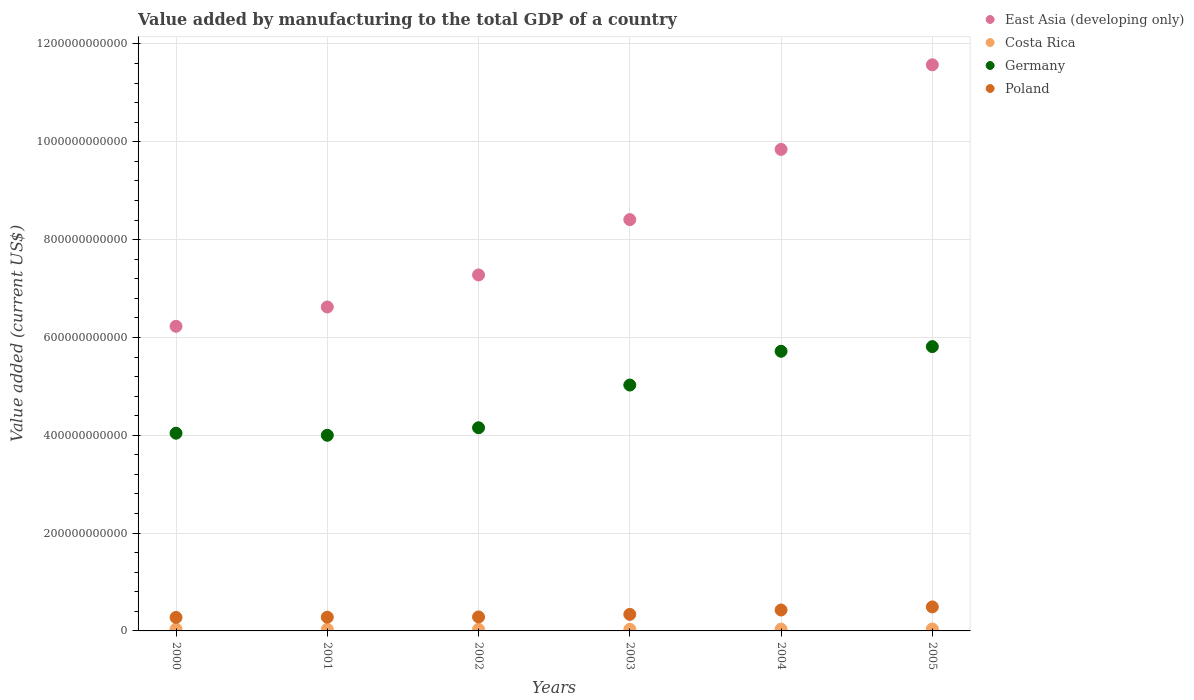How many different coloured dotlines are there?
Provide a succinct answer. 4. Is the number of dotlines equal to the number of legend labels?
Your response must be concise. Yes. What is the value added by manufacturing to the total GDP in Costa Rica in 2004?
Your answer should be very brief. 3.66e+09. Across all years, what is the maximum value added by manufacturing to the total GDP in Costa Rica?
Your answer should be very brief. 3.91e+09. Across all years, what is the minimum value added by manufacturing to the total GDP in East Asia (developing only)?
Your answer should be very brief. 6.23e+11. In which year was the value added by manufacturing to the total GDP in Germany maximum?
Your answer should be very brief. 2005. What is the total value added by manufacturing to the total GDP in Germany in the graph?
Your answer should be compact. 2.88e+12. What is the difference between the value added by manufacturing to the total GDP in East Asia (developing only) in 2000 and that in 2004?
Ensure brevity in your answer.  -3.62e+11. What is the difference between the value added by manufacturing to the total GDP in Poland in 2003 and the value added by manufacturing to the total GDP in East Asia (developing only) in 2005?
Make the answer very short. -1.12e+12. What is the average value added by manufacturing to the total GDP in Costa Rica per year?
Give a very brief answer. 3.52e+09. In the year 2005, what is the difference between the value added by manufacturing to the total GDP in Germany and value added by manufacturing to the total GDP in Costa Rica?
Your response must be concise. 5.77e+11. In how many years, is the value added by manufacturing to the total GDP in Germany greater than 720000000000 US$?
Offer a very short reply. 0. What is the ratio of the value added by manufacturing to the total GDP in East Asia (developing only) in 2001 to that in 2002?
Keep it short and to the point. 0.91. Is the value added by manufacturing to the total GDP in Poland in 2004 less than that in 2005?
Provide a short and direct response. Yes. What is the difference between the highest and the second highest value added by manufacturing to the total GDP in Poland?
Offer a very short reply. 6.30e+09. What is the difference between the highest and the lowest value added by manufacturing to the total GDP in Poland?
Offer a terse response. 2.16e+1. Is the sum of the value added by manufacturing to the total GDP in Germany in 2003 and 2005 greater than the maximum value added by manufacturing to the total GDP in East Asia (developing only) across all years?
Make the answer very short. No. Is it the case that in every year, the sum of the value added by manufacturing to the total GDP in Poland and value added by manufacturing to the total GDP in Costa Rica  is greater than the value added by manufacturing to the total GDP in Germany?
Provide a short and direct response. No. Does the value added by manufacturing to the total GDP in Germany monotonically increase over the years?
Provide a short and direct response. No. Is the value added by manufacturing to the total GDP in Germany strictly greater than the value added by manufacturing to the total GDP in Poland over the years?
Give a very brief answer. Yes. Is the value added by manufacturing to the total GDP in Germany strictly less than the value added by manufacturing to the total GDP in Costa Rica over the years?
Ensure brevity in your answer.  No. What is the difference between two consecutive major ticks on the Y-axis?
Give a very brief answer. 2.00e+11. Are the values on the major ticks of Y-axis written in scientific E-notation?
Provide a succinct answer. No. Does the graph contain any zero values?
Provide a short and direct response. No. Where does the legend appear in the graph?
Provide a short and direct response. Top right. How many legend labels are there?
Give a very brief answer. 4. What is the title of the graph?
Offer a very short reply. Value added by manufacturing to the total GDP of a country. What is the label or title of the X-axis?
Keep it short and to the point. Years. What is the label or title of the Y-axis?
Provide a short and direct response. Value added (current US$). What is the Value added (current US$) of East Asia (developing only) in 2000?
Provide a succinct answer. 6.23e+11. What is the Value added (current US$) of Costa Rica in 2000?
Provide a short and direct response. 3.68e+09. What is the Value added (current US$) of Germany in 2000?
Keep it short and to the point. 4.04e+11. What is the Value added (current US$) of Poland in 2000?
Offer a terse response. 2.75e+1. What is the Value added (current US$) in East Asia (developing only) in 2001?
Give a very brief answer. 6.62e+11. What is the Value added (current US$) of Costa Rica in 2001?
Offer a terse response. 3.24e+09. What is the Value added (current US$) in Germany in 2001?
Give a very brief answer. 4.00e+11. What is the Value added (current US$) of Poland in 2001?
Ensure brevity in your answer.  2.81e+1. What is the Value added (current US$) of East Asia (developing only) in 2002?
Your answer should be very brief. 7.28e+11. What is the Value added (current US$) of Costa Rica in 2002?
Your answer should be very brief. 3.28e+09. What is the Value added (current US$) in Germany in 2002?
Your answer should be compact. 4.15e+11. What is the Value added (current US$) of Poland in 2002?
Your answer should be very brief. 2.85e+1. What is the Value added (current US$) in East Asia (developing only) in 2003?
Provide a short and direct response. 8.41e+11. What is the Value added (current US$) in Costa Rica in 2003?
Ensure brevity in your answer.  3.36e+09. What is the Value added (current US$) of Germany in 2003?
Your answer should be very brief. 5.03e+11. What is the Value added (current US$) of Poland in 2003?
Give a very brief answer. 3.39e+1. What is the Value added (current US$) of East Asia (developing only) in 2004?
Your answer should be very brief. 9.84e+11. What is the Value added (current US$) in Costa Rica in 2004?
Give a very brief answer. 3.66e+09. What is the Value added (current US$) in Germany in 2004?
Your answer should be compact. 5.72e+11. What is the Value added (current US$) of Poland in 2004?
Your response must be concise. 4.28e+1. What is the Value added (current US$) in East Asia (developing only) in 2005?
Your answer should be compact. 1.16e+12. What is the Value added (current US$) of Costa Rica in 2005?
Offer a terse response. 3.91e+09. What is the Value added (current US$) in Germany in 2005?
Offer a terse response. 5.81e+11. What is the Value added (current US$) of Poland in 2005?
Offer a terse response. 4.91e+1. Across all years, what is the maximum Value added (current US$) in East Asia (developing only)?
Make the answer very short. 1.16e+12. Across all years, what is the maximum Value added (current US$) in Costa Rica?
Your answer should be very brief. 3.91e+09. Across all years, what is the maximum Value added (current US$) of Germany?
Your response must be concise. 5.81e+11. Across all years, what is the maximum Value added (current US$) in Poland?
Your answer should be compact. 4.91e+1. Across all years, what is the minimum Value added (current US$) of East Asia (developing only)?
Your response must be concise. 6.23e+11. Across all years, what is the minimum Value added (current US$) in Costa Rica?
Offer a very short reply. 3.24e+09. Across all years, what is the minimum Value added (current US$) in Germany?
Ensure brevity in your answer.  4.00e+11. Across all years, what is the minimum Value added (current US$) of Poland?
Keep it short and to the point. 2.75e+1. What is the total Value added (current US$) of East Asia (developing only) in the graph?
Your answer should be very brief. 5.00e+12. What is the total Value added (current US$) in Costa Rica in the graph?
Give a very brief answer. 2.11e+1. What is the total Value added (current US$) in Germany in the graph?
Your answer should be very brief. 2.88e+12. What is the total Value added (current US$) of Poland in the graph?
Make the answer very short. 2.10e+11. What is the difference between the Value added (current US$) of East Asia (developing only) in 2000 and that in 2001?
Offer a terse response. -3.94e+1. What is the difference between the Value added (current US$) in Costa Rica in 2000 and that in 2001?
Provide a short and direct response. 4.34e+08. What is the difference between the Value added (current US$) of Germany in 2000 and that in 2001?
Keep it short and to the point. 4.21e+09. What is the difference between the Value added (current US$) of Poland in 2000 and that in 2001?
Keep it short and to the point. -5.80e+08. What is the difference between the Value added (current US$) in East Asia (developing only) in 2000 and that in 2002?
Your response must be concise. -1.05e+11. What is the difference between the Value added (current US$) of Costa Rica in 2000 and that in 2002?
Give a very brief answer. 4.00e+08. What is the difference between the Value added (current US$) in Germany in 2000 and that in 2002?
Give a very brief answer. -1.12e+1. What is the difference between the Value added (current US$) of Poland in 2000 and that in 2002?
Provide a succinct answer. -1.02e+09. What is the difference between the Value added (current US$) in East Asia (developing only) in 2000 and that in 2003?
Your answer should be very brief. -2.18e+11. What is the difference between the Value added (current US$) of Costa Rica in 2000 and that in 2003?
Offer a very short reply. 3.16e+08. What is the difference between the Value added (current US$) of Germany in 2000 and that in 2003?
Provide a succinct answer. -9.85e+1. What is the difference between the Value added (current US$) of Poland in 2000 and that in 2003?
Provide a short and direct response. -6.33e+09. What is the difference between the Value added (current US$) in East Asia (developing only) in 2000 and that in 2004?
Offer a very short reply. -3.62e+11. What is the difference between the Value added (current US$) in Costa Rica in 2000 and that in 2004?
Offer a very short reply. 1.61e+07. What is the difference between the Value added (current US$) of Germany in 2000 and that in 2004?
Make the answer very short. -1.68e+11. What is the difference between the Value added (current US$) in Poland in 2000 and that in 2004?
Your response must be concise. -1.53e+1. What is the difference between the Value added (current US$) in East Asia (developing only) in 2000 and that in 2005?
Your answer should be very brief. -5.35e+11. What is the difference between the Value added (current US$) in Costa Rica in 2000 and that in 2005?
Keep it short and to the point. -2.38e+08. What is the difference between the Value added (current US$) in Germany in 2000 and that in 2005?
Make the answer very short. -1.77e+11. What is the difference between the Value added (current US$) of Poland in 2000 and that in 2005?
Your answer should be very brief. -2.16e+1. What is the difference between the Value added (current US$) in East Asia (developing only) in 2001 and that in 2002?
Provide a short and direct response. -6.55e+1. What is the difference between the Value added (current US$) of Costa Rica in 2001 and that in 2002?
Provide a succinct answer. -3.42e+07. What is the difference between the Value added (current US$) of Germany in 2001 and that in 2002?
Offer a terse response. -1.54e+1. What is the difference between the Value added (current US$) of Poland in 2001 and that in 2002?
Make the answer very short. -4.39e+08. What is the difference between the Value added (current US$) of East Asia (developing only) in 2001 and that in 2003?
Give a very brief answer. -1.79e+11. What is the difference between the Value added (current US$) in Costa Rica in 2001 and that in 2003?
Offer a terse response. -1.18e+08. What is the difference between the Value added (current US$) of Germany in 2001 and that in 2003?
Your answer should be very brief. -1.03e+11. What is the difference between the Value added (current US$) of Poland in 2001 and that in 2003?
Make the answer very short. -5.75e+09. What is the difference between the Value added (current US$) of East Asia (developing only) in 2001 and that in 2004?
Keep it short and to the point. -3.22e+11. What is the difference between the Value added (current US$) of Costa Rica in 2001 and that in 2004?
Keep it short and to the point. -4.18e+08. What is the difference between the Value added (current US$) in Germany in 2001 and that in 2004?
Provide a short and direct response. -1.72e+11. What is the difference between the Value added (current US$) of Poland in 2001 and that in 2004?
Your answer should be compact. -1.47e+1. What is the difference between the Value added (current US$) in East Asia (developing only) in 2001 and that in 2005?
Offer a terse response. -4.95e+11. What is the difference between the Value added (current US$) of Costa Rica in 2001 and that in 2005?
Provide a short and direct response. -6.72e+08. What is the difference between the Value added (current US$) of Germany in 2001 and that in 2005?
Offer a very short reply. -1.81e+11. What is the difference between the Value added (current US$) of Poland in 2001 and that in 2005?
Give a very brief answer. -2.10e+1. What is the difference between the Value added (current US$) in East Asia (developing only) in 2002 and that in 2003?
Make the answer very short. -1.13e+11. What is the difference between the Value added (current US$) of Costa Rica in 2002 and that in 2003?
Your answer should be compact. -8.42e+07. What is the difference between the Value added (current US$) in Germany in 2002 and that in 2003?
Your answer should be very brief. -8.73e+1. What is the difference between the Value added (current US$) in Poland in 2002 and that in 2003?
Make the answer very short. -5.31e+09. What is the difference between the Value added (current US$) in East Asia (developing only) in 2002 and that in 2004?
Ensure brevity in your answer.  -2.57e+11. What is the difference between the Value added (current US$) in Costa Rica in 2002 and that in 2004?
Keep it short and to the point. -3.84e+08. What is the difference between the Value added (current US$) of Germany in 2002 and that in 2004?
Make the answer very short. -1.56e+11. What is the difference between the Value added (current US$) of Poland in 2002 and that in 2004?
Make the answer very short. -1.42e+1. What is the difference between the Value added (current US$) of East Asia (developing only) in 2002 and that in 2005?
Ensure brevity in your answer.  -4.30e+11. What is the difference between the Value added (current US$) of Costa Rica in 2002 and that in 2005?
Provide a succinct answer. -6.38e+08. What is the difference between the Value added (current US$) in Germany in 2002 and that in 2005?
Ensure brevity in your answer.  -1.66e+11. What is the difference between the Value added (current US$) in Poland in 2002 and that in 2005?
Offer a terse response. -2.05e+1. What is the difference between the Value added (current US$) of East Asia (developing only) in 2003 and that in 2004?
Ensure brevity in your answer.  -1.44e+11. What is the difference between the Value added (current US$) of Costa Rica in 2003 and that in 2004?
Offer a terse response. -3.00e+08. What is the difference between the Value added (current US$) in Germany in 2003 and that in 2004?
Keep it short and to the point. -6.90e+1. What is the difference between the Value added (current US$) of Poland in 2003 and that in 2004?
Make the answer very short. -8.92e+09. What is the difference between the Value added (current US$) of East Asia (developing only) in 2003 and that in 2005?
Give a very brief answer. -3.17e+11. What is the difference between the Value added (current US$) of Costa Rica in 2003 and that in 2005?
Offer a terse response. -5.53e+08. What is the difference between the Value added (current US$) in Germany in 2003 and that in 2005?
Ensure brevity in your answer.  -7.86e+1. What is the difference between the Value added (current US$) in Poland in 2003 and that in 2005?
Offer a very short reply. -1.52e+1. What is the difference between the Value added (current US$) of East Asia (developing only) in 2004 and that in 2005?
Ensure brevity in your answer.  -1.73e+11. What is the difference between the Value added (current US$) of Costa Rica in 2004 and that in 2005?
Give a very brief answer. -2.54e+08. What is the difference between the Value added (current US$) of Germany in 2004 and that in 2005?
Give a very brief answer. -9.54e+09. What is the difference between the Value added (current US$) in Poland in 2004 and that in 2005?
Offer a terse response. -6.30e+09. What is the difference between the Value added (current US$) in East Asia (developing only) in 2000 and the Value added (current US$) in Costa Rica in 2001?
Your answer should be very brief. 6.20e+11. What is the difference between the Value added (current US$) of East Asia (developing only) in 2000 and the Value added (current US$) of Germany in 2001?
Make the answer very short. 2.23e+11. What is the difference between the Value added (current US$) of East Asia (developing only) in 2000 and the Value added (current US$) of Poland in 2001?
Provide a succinct answer. 5.95e+11. What is the difference between the Value added (current US$) of Costa Rica in 2000 and the Value added (current US$) of Germany in 2001?
Provide a short and direct response. -3.96e+11. What is the difference between the Value added (current US$) of Costa Rica in 2000 and the Value added (current US$) of Poland in 2001?
Make the answer very short. -2.44e+1. What is the difference between the Value added (current US$) of Germany in 2000 and the Value added (current US$) of Poland in 2001?
Your answer should be compact. 3.76e+11. What is the difference between the Value added (current US$) in East Asia (developing only) in 2000 and the Value added (current US$) in Costa Rica in 2002?
Your response must be concise. 6.20e+11. What is the difference between the Value added (current US$) of East Asia (developing only) in 2000 and the Value added (current US$) of Germany in 2002?
Provide a short and direct response. 2.07e+11. What is the difference between the Value added (current US$) in East Asia (developing only) in 2000 and the Value added (current US$) in Poland in 2002?
Your answer should be very brief. 5.94e+11. What is the difference between the Value added (current US$) in Costa Rica in 2000 and the Value added (current US$) in Germany in 2002?
Provide a succinct answer. -4.12e+11. What is the difference between the Value added (current US$) of Costa Rica in 2000 and the Value added (current US$) of Poland in 2002?
Your answer should be compact. -2.49e+1. What is the difference between the Value added (current US$) in Germany in 2000 and the Value added (current US$) in Poland in 2002?
Keep it short and to the point. 3.76e+11. What is the difference between the Value added (current US$) of East Asia (developing only) in 2000 and the Value added (current US$) of Costa Rica in 2003?
Make the answer very short. 6.19e+11. What is the difference between the Value added (current US$) of East Asia (developing only) in 2000 and the Value added (current US$) of Germany in 2003?
Give a very brief answer. 1.20e+11. What is the difference between the Value added (current US$) in East Asia (developing only) in 2000 and the Value added (current US$) in Poland in 2003?
Your answer should be very brief. 5.89e+11. What is the difference between the Value added (current US$) in Costa Rica in 2000 and the Value added (current US$) in Germany in 2003?
Make the answer very short. -4.99e+11. What is the difference between the Value added (current US$) in Costa Rica in 2000 and the Value added (current US$) in Poland in 2003?
Offer a very short reply. -3.02e+1. What is the difference between the Value added (current US$) of Germany in 2000 and the Value added (current US$) of Poland in 2003?
Make the answer very short. 3.70e+11. What is the difference between the Value added (current US$) in East Asia (developing only) in 2000 and the Value added (current US$) in Costa Rica in 2004?
Provide a short and direct response. 6.19e+11. What is the difference between the Value added (current US$) in East Asia (developing only) in 2000 and the Value added (current US$) in Germany in 2004?
Provide a short and direct response. 5.11e+1. What is the difference between the Value added (current US$) of East Asia (developing only) in 2000 and the Value added (current US$) of Poland in 2004?
Your answer should be compact. 5.80e+11. What is the difference between the Value added (current US$) in Costa Rica in 2000 and the Value added (current US$) in Germany in 2004?
Provide a short and direct response. -5.68e+11. What is the difference between the Value added (current US$) of Costa Rica in 2000 and the Value added (current US$) of Poland in 2004?
Ensure brevity in your answer.  -3.91e+1. What is the difference between the Value added (current US$) in Germany in 2000 and the Value added (current US$) in Poland in 2004?
Ensure brevity in your answer.  3.61e+11. What is the difference between the Value added (current US$) of East Asia (developing only) in 2000 and the Value added (current US$) of Costa Rica in 2005?
Provide a short and direct response. 6.19e+11. What is the difference between the Value added (current US$) in East Asia (developing only) in 2000 and the Value added (current US$) in Germany in 2005?
Make the answer very short. 4.16e+1. What is the difference between the Value added (current US$) of East Asia (developing only) in 2000 and the Value added (current US$) of Poland in 2005?
Offer a terse response. 5.74e+11. What is the difference between the Value added (current US$) of Costa Rica in 2000 and the Value added (current US$) of Germany in 2005?
Offer a very short reply. -5.78e+11. What is the difference between the Value added (current US$) in Costa Rica in 2000 and the Value added (current US$) in Poland in 2005?
Your answer should be very brief. -4.54e+1. What is the difference between the Value added (current US$) in Germany in 2000 and the Value added (current US$) in Poland in 2005?
Your answer should be very brief. 3.55e+11. What is the difference between the Value added (current US$) in East Asia (developing only) in 2001 and the Value added (current US$) in Costa Rica in 2002?
Offer a terse response. 6.59e+11. What is the difference between the Value added (current US$) of East Asia (developing only) in 2001 and the Value added (current US$) of Germany in 2002?
Offer a terse response. 2.47e+11. What is the difference between the Value added (current US$) in East Asia (developing only) in 2001 and the Value added (current US$) in Poland in 2002?
Offer a very short reply. 6.34e+11. What is the difference between the Value added (current US$) in Costa Rica in 2001 and the Value added (current US$) in Germany in 2002?
Give a very brief answer. -4.12e+11. What is the difference between the Value added (current US$) of Costa Rica in 2001 and the Value added (current US$) of Poland in 2002?
Provide a short and direct response. -2.53e+1. What is the difference between the Value added (current US$) in Germany in 2001 and the Value added (current US$) in Poland in 2002?
Your response must be concise. 3.71e+11. What is the difference between the Value added (current US$) of East Asia (developing only) in 2001 and the Value added (current US$) of Costa Rica in 2003?
Your response must be concise. 6.59e+11. What is the difference between the Value added (current US$) of East Asia (developing only) in 2001 and the Value added (current US$) of Germany in 2003?
Your answer should be compact. 1.60e+11. What is the difference between the Value added (current US$) in East Asia (developing only) in 2001 and the Value added (current US$) in Poland in 2003?
Offer a terse response. 6.28e+11. What is the difference between the Value added (current US$) in Costa Rica in 2001 and the Value added (current US$) in Germany in 2003?
Your response must be concise. -4.99e+11. What is the difference between the Value added (current US$) in Costa Rica in 2001 and the Value added (current US$) in Poland in 2003?
Provide a short and direct response. -3.06e+1. What is the difference between the Value added (current US$) in Germany in 2001 and the Value added (current US$) in Poland in 2003?
Ensure brevity in your answer.  3.66e+11. What is the difference between the Value added (current US$) of East Asia (developing only) in 2001 and the Value added (current US$) of Costa Rica in 2004?
Offer a very short reply. 6.59e+11. What is the difference between the Value added (current US$) of East Asia (developing only) in 2001 and the Value added (current US$) of Germany in 2004?
Provide a short and direct response. 9.05e+1. What is the difference between the Value added (current US$) of East Asia (developing only) in 2001 and the Value added (current US$) of Poland in 2004?
Offer a very short reply. 6.19e+11. What is the difference between the Value added (current US$) of Costa Rica in 2001 and the Value added (current US$) of Germany in 2004?
Give a very brief answer. -5.68e+11. What is the difference between the Value added (current US$) in Costa Rica in 2001 and the Value added (current US$) in Poland in 2004?
Your answer should be compact. -3.95e+1. What is the difference between the Value added (current US$) in Germany in 2001 and the Value added (current US$) in Poland in 2004?
Make the answer very short. 3.57e+11. What is the difference between the Value added (current US$) of East Asia (developing only) in 2001 and the Value added (current US$) of Costa Rica in 2005?
Give a very brief answer. 6.58e+11. What is the difference between the Value added (current US$) in East Asia (developing only) in 2001 and the Value added (current US$) in Germany in 2005?
Offer a very short reply. 8.10e+1. What is the difference between the Value added (current US$) in East Asia (developing only) in 2001 and the Value added (current US$) in Poland in 2005?
Offer a very short reply. 6.13e+11. What is the difference between the Value added (current US$) of Costa Rica in 2001 and the Value added (current US$) of Germany in 2005?
Offer a terse response. -5.78e+11. What is the difference between the Value added (current US$) in Costa Rica in 2001 and the Value added (current US$) in Poland in 2005?
Make the answer very short. -4.58e+1. What is the difference between the Value added (current US$) in Germany in 2001 and the Value added (current US$) in Poland in 2005?
Keep it short and to the point. 3.51e+11. What is the difference between the Value added (current US$) in East Asia (developing only) in 2002 and the Value added (current US$) in Costa Rica in 2003?
Ensure brevity in your answer.  7.24e+11. What is the difference between the Value added (current US$) of East Asia (developing only) in 2002 and the Value added (current US$) of Germany in 2003?
Your answer should be very brief. 2.25e+11. What is the difference between the Value added (current US$) in East Asia (developing only) in 2002 and the Value added (current US$) in Poland in 2003?
Offer a terse response. 6.94e+11. What is the difference between the Value added (current US$) in Costa Rica in 2002 and the Value added (current US$) in Germany in 2003?
Give a very brief answer. -4.99e+11. What is the difference between the Value added (current US$) of Costa Rica in 2002 and the Value added (current US$) of Poland in 2003?
Provide a short and direct response. -3.06e+1. What is the difference between the Value added (current US$) in Germany in 2002 and the Value added (current US$) in Poland in 2003?
Keep it short and to the point. 3.81e+11. What is the difference between the Value added (current US$) of East Asia (developing only) in 2002 and the Value added (current US$) of Costa Rica in 2004?
Offer a terse response. 7.24e+11. What is the difference between the Value added (current US$) of East Asia (developing only) in 2002 and the Value added (current US$) of Germany in 2004?
Ensure brevity in your answer.  1.56e+11. What is the difference between the Value added (current US$) in East Asia (developing only) in 2002 and the Value added (current US$) in Poland in 2004?
Your response must be concise. 6.85e+11. What is the difference between the Value added (current US$) in Costa Rica in 2002 and the Value added (current US$) in Germany in 2004?
Provide a succinct answer. -5.68e+11. What is the difference between the Value added (current US$) of Costa Rica in 2002 and the Value added (current US$) of Poland in 2004?
Your answer should be compact. -3.95e+1. What is the difference between the Value added (current US$) in Germany in 2002 and the Value added (current US$) in Poland in 2004?
Keep it short and to the point. 3.73e+11. What is the difference between the Value added (current US$) of East Asia (developing only) in 2002 and the Value added (current US$) of Costa Rica in 2005?
Keep it short and to the point. 7.24e+11. What is the difference between the Value added (current US$) in East Asia (developing only) in 2002 and the Value added (current US$) in Germany in 2005?
Provide a succinct answer. 1.47e+11. What is the difference between the Value added (current US$) in East Asia (developing only) in 2002 and the Value added (current US$) in Poland in 2005?
Keep it short and to the point. 6.79e+11. What is the difference between the Value added (current US$) in Costa Rica in 2002 and the Value added (current US$) in Germany in 2005?
Ensure brevity in your answer.  -5.78e+11. What is the difference between the Value added (current US$) of Costa Rica in 2002 and the Value added (current US$) of Poland in 2005?
Your response must be concise. -4.58e+1. What is the difference between the Value added (current US$) of Germany in 2002 and the Value added (current US$) of Poland in 2005?
Your response must be concise. 3.66e+11. What is the difference between the Value added (current US$) of East Asia (developing only) in 2003 and the Value added (current US$) of Costa Rica in 2004?
Keep it short and to the point. 8.37e+11. What is the difference between the Value added (current US$) of East Asia (developing only) in 2003 and the Value added (current US$) of Germany in 2004?
Give a very brief answer. 2.69e+11. What is the difference between the Value added (current US$) of East Asia (developing only) in 2003 and the Value added (current US$) of Poland in 2004?
Offer a terse response. 7.98e+11. What is the difference between the Value added (current US$) of Costa Rica in 2003 and the Value added (current US$) of Germany in 2004?
Your response must be concise. -5.68e+11. What is the difference between the Value added (current US$) in Costa Rica in 2003 and the Value added (current US$) in Poland in 2004?
Keep it short and to the point. -3.94e+1. What is the difference between the Value added (current US$) of Germany in 2003 and the Value added (current US$) of Poland in 2004?
Make the answer very short. 4.60e+11. What is the difference between the Value added (current US$) of East Asia (developing only) in 2003 and the Value added (current US$) of Costa Rica in 2005?
Offer a very short reply. 8.37e+11. What is the difference between the Value added (current US$) in East Asia (developing only) in 2003 and the Value added (current US$) in Germany in 2005?
Provide a short and direct response. 2.60e+11. What is the difference between the Value added (current US$) of East Asia (developing only) in 2003 and the Value added (current US$) of Poland in 2005?
Ensure brevity in your answer.  7.92e+11. What is the difference between the Value added (current US$) in Costa Rica in 2003 and the Value added (current US$) in Germany in 2005?
Ensure brevity in your answer.  -5.78e+11. What is the difference between the Value added (current US$) in Costa Rica in 2003 and the Value added (current US$) in Poland in 2005?
Ensure brevity in your answer.  -4.57e+1. What is the difference between the Value added (current US$) in Germany in 2003 and the Value added (current US$) in Poland in 2005?
Provide a succinct answer. 4.54e+11. What is the difference between the Value added (current US$) of East Asia (developing only) in 2004 and the Value added (current US$) of Costa Rica in 2005?
Ensure brevity in your answer.  9.81e+11. What is the difference between the Value added (current US$) in East Asia (developing only) in 2004 and the Value added (current US$) in Germany in 2005?
Ensure brevity in your answer.  4.03e+11. What is the difference between the Value added (current US$) in East Asia (developing only) in 2004 and the Value added (current US$) in Poland in 2005?
Ensure brevity in your answer.  9.35e+11. What is the difference between the Value added (current US$) of Costa Rica in 2004 and the Value added (current US$) of Germany in 2005?
Ensure brevity in your answer.  -5.78e+11. What is the difference between the Value added (current US$) in Costa Rica in 2004 and the Value added (current US$) in Poland in 2005?
Give a very brief answer. -4.54e+1. What is the difference between the Value added (current US$) in Germany in 2004 and the Value added (current US$) in Poland in 2005?
Provide a succinct answer. 5.23e+11. What is the average Value added (current US$) in East Asia (developing only) per year?
Ensure brevity in your answer.  8.33e+11. What is the average Value added (current US$) of Costa Rica per year?
Your response must be concise. 3.52e+09. What is the average Value added (current US$) of Germany per year?
Provide a succinct answer. 4.79e+11. What is the average Value added (current US$) of Poland per year?
Your response must be concise. 3.50e+1. In the year 2000, what is the difference between the Value added (current US$) of East Asia (developing only) and Value added (current US$) of Costa Rica?
Provide a succinct answer. 6.19e+11. In the year 2000, what is the difference between the Value added (current US$) of East Asia (developing only) and Value added (current US$) of Germany?
Your answer should be compact. 2.19e+11. In the year 2000, what is the difference between the Value added (current US$) of East Asia (developing only) and Value added (current US$) of Poland?
Your answer should be very brief. 5.95e+11. In the year 2000, what is the difference between the Value added (current US$) of Costa Rica and Value added (current US$) of Germany?
Your answer should be very brief. -4.01e+11. In the year 2000, what is the difference between the Value added (current US$) of Costa Rica and Value added (current US$) of Poland?
Your answer should be very brief. -2.39e+1. In the year 2000, what is the difference between the Value added (current US$) in Germany and Value added (current US$) in Poland?
Make the answer very short. 3.77e+11. In the year 2001, what is the difference between the Value added (current US$) in East Asia (developing only) and Value added (current US$) in Costa Rica?
Give a very brief answer. 6.59e+11. In the year 2001, what is the difference between the Value added (current US$) of East Asia (developing only) and Value added (current US$) of Germany?
Your answer should be compact. 2.62e+11. In the year 2001, what is the difference between the Value added (current US$) of East Asia (developing only) and Value added (current US$) of Poland?
Your response must be concise. 6.34e+11. In the year 2001, what is the difference between the Value added (current US$) in Costa Rica and Value added (current US$) in Germany?
Your response must be concise. -3.97e+11. In the year 2001, what is the difference between the Value added (current US$) in Costa Rica and Value added (current US$) in Poland?
Your response must be concise. -2.49e+1. In the year 2001, what is the difference between the Value added (current US$) in Germany and Value added (current US$) in Poland?
Ensure brevity in your answer.  3.72e+11. In the year 2002, what is the difference between the Value added (current US$) in East Asia (developing only) and Value added (current US$) in Costa Rica?
Provide a succinct answer. 7.24e+11. In the year 2002, what is the difference between the Value added (current US$) of East Asia (developing only) and Value added (current US$) of Germany?
Make the answer very short. 3.12e+11. In the year 2002, what is the difference between the Value added (current US$) in East Asia (developing only) and Value added (current US$) in Poland?
Your response must be concise. 6.99e+11. In the year 2002, what is the difference between the Value added (current US$) in Costa Rica and Value added (current US$) in Germany?
Provide a succinct answer. -4.12e+11. In the year 2002, what is the difference between the Value added (current US$) in Costa Rica and Value added (current US$) in Poland?
Offer a terse response. -2.53e+1. In the year 2002, what is the difference between the Value added (current US$) in Germany and Value added (current US$) in Poland?
Keep it short and to the point. 3.87e+11. In the year 2003, what is the difference between the Value added (current US$) of East Asia (developing only) and Value added (current US$) of Costa Rica?
Ensure brevity in your answer.  8.38e+11. In the year 2003, what is the difference between the Value added (current US$) of East Asia (developing only) and Value added (current US$) of Germany?
Keep it short and to the point. 3.38e+11. In the year 2003, what is the difference between the Value added (current US$) of East Asia (developing only) and Value added (current US$) of Poland?
Your answer should be compact. 8.07e+11. In the year 2003, what is the difference between the Value added (current US$) in Costa Rica and Value added (current US$) in Germany?
Offer a terse response. -4.99e+11. In the year 2003, what is the difference between the Value added (current US$) of Costa Rica and Value added (current US$) of Poland?
Give a very brief answer. -3.05e+1. In the year 2003, what is the difference between the Value added (current US$) of Germany and Value added (current US$) of Poland?
Offer a very short reply. 4.69e+11. In the year 2004, what is the difference between the Value added (current US$) of East Asia (developing only) and Value added (current US$) of Costa Rica?
Ensure brevity in your answer.  9.81e+11. In the year 2004, what is the difference between the Value added (current US$) of East Asia (developing only) and Value added (current US$) of Germany?
Your answer should be very brief. 4.13e+11. In the year 2004, what is the difference between the Value added (current US$) in East Asia (developing only) and Value added (current US$) in Poland?
Ensure brevity in your answer.  9.42e+11. In the year 2004, what is the difference between the Value added (current US$) in Costa Rica and Value added (current US$) in Germany?
Make the answer very short. -5.68e+11. In the year 2004, what is the difference between the Value added (current US$) of Costa Rica and Value added (current US$) of Poland?
Offer a terse response. -3.91e+1. In the year 2004, what is the difference between the Value added (current US$) in Germany and Value added (current US$) in Poland?
Your answer should be compact. 5.29e+11. In the year 2005, what is the difference between the Value added (current US$) of East Asia (developing only) and Value added (current US$) of Costa Rica?
Your answer should be very brief. 1.15e+12. In the year 2005, what is the difference between the Value added (current US$) in East Asia (developing only) and Value added (current US$) in Germany?
Give a very brief answer. 5.76e+11. In the year 2005, what is the difference between the Value added (current US$) of East Asia (developing only) and Value added (current US$) of Poland?
Your answer should be compact. 1.11e+12. In the year 2005, what is the difference between the Value added (current US$) in Costa Rica and Value added (current US$) in Germany?
Your response must be concise. -5.77e+11. In the year 2005, what is the difference between the Value added (current US$) of Costa Rica and Value added (current US$) of Poland?
Your answer should be compact. -4.52e+1. In the year 2005, what is the difference between the Value added (current US$) in Germany and Value added (current US$) in Poland?
Your response must be concise. 5.32e+11. What is the ratio of the Value added (current US$) in East Asia (developing only) in 2000 to that in 2001?
Your response must be concise. 0.94. What is the ratio of the Value added (current US$) in Costa Rica in 2000 to that in 2001?
Offer a very short reply. 1.13. What is the ratio of the Value added (current US$) of Germany in 2000 to that in 2001?
Your response must be concise. 1.01. What is the ratio of the Value added (current US$) in Poland in 2000 to that in 2001?
Offer a very short reply. 0.98. What is the ratio of the Value added (current US$) of East Asia (developing only) in 2000 to that in 2002?
Provide a short and direct response. 0.86. What is the ratio of the Value added (current US$) in Costa Rica in 2000 to that in 2002?
Make the answer very short. 1.12. What is the ratio of the Value added (current US$) in Germany in 2000 to that in 2002?
Provide a succinct answer. 0.97. What is the ratio of the Value added (current US$) in East Asia (developing only) in 2000 to that in 2003?
Your response must be concise. 0.74. What is the ratio of the Value added (current US$) in Costa Rica in 2000 to that in 2003?
Your answer should be very brief. 1.09. What is the ratio of the Value added (current US$) of Germany in 2000 to that in 2003?
Offer a very short reply. 0.8. What is the ratio of the Value added (current US$) in Poland in 2000 to that in 2003?
Ensure brevity in your answer.  0.81. What is the ratio of the Value added (current US$) of East Asia (developing only) in 2000 to that in 2004?
Keep it short and to the point. 0.63. What is the ratio of the Value added (current US$) of Germany in 2000 to that in 2004?
Your answer should be very brief. 0.71. What is the ratio of the Value added (current US$) of Poland in 2000 to that in 2004?
Give a very brief answer. 0.64. What is the ratio of the Value added (current US$) in East Asia (developing only) in 2000 to that in 2005?
Your answer should be compact. 0.54. What is the ratio of the Value added (current US$) in Costa Rica in 2000 to that in 2005?
Offer a terse response. 0.94. What is the ratio of the Value added (current US$) of Germany in 2000 to that in 2005?
Your answer should be very brief. 0.7. What is the ratio of the Value added (current US$) of Poland in 2000 to that in 2005?
Offer a terse response. 0.56. What is the ratio of the Value added (current US$) in East Asia (developing only) in 2001 to that in 2002?
Provide a short and direct response. 0.91. What is the ratio of the Value added (current US$) in Costa Rica in 2001 to that in 2002?
Your response must be concise. 0.99. What is the ratio of the Value added (current US$) of Poland in 2001 to that in 2002?
Provide a succinct answer. 0.98. What is the ratio of the Value added (current US$) of East Asia (developing only) in 2001 to that in 2003?
Provide a short and direct response. 0.79. What is the ratio of the Value added (current US$) in Costa Rica in 2001 to that in 2003?
Keep it short and to the point. 0.96. What is the ratio of the Value added (current US$) in Germany in 2001 to that in 2003?
Make the answer very short. 0.8. What is the ratio of the Value added (current US$) in Poland in 2001 to that in 2003?
Your answer should be compact. 0.83. What is the ratio of the Value added (current US$) in East Asia (developing only) in 2001 to that in 2004?
Make the answer very short. 0.67. What is the ratio of the Value added (current US$) of Costa Rica in 2001 to that in 2004?
Offer a very short reply. 0.89. What is the ratio of the Value added (current US$) of Germany in 2001 to that in 2004?
Offer a terse response. 0.7. What is the ratio of the Value added (current US$) of Poland in 2001 to that in 2004?
Make the answer very short. 0.66. What is the ratio of the Value added (current US$) of East Asia (developing only) in 2001 to that in 2005?
Ensure brevity in your answer.  0.57. What is the ratio of the Value added (current US$) of Costa Rica in 2001 to that in 2005?
Keep it short and to the point. 0.83. What is the ratio of the Value added (current US$) in Germany in 2001 to that in 2005?
Give a very brief answer. 0.69. What is the ratio of the Value added (current US$) in Poland in 2001 to that in 2005?
Your answer should be compact. 0.57. What is the ratio of the Value added (current US$) of East Asia (developing only) in 2002 to that in 2003?
Your response must be concise. 0.87. What is the ratio of the Value added (current US$) in Costa Rica in 2002 to that in 2003?
Offer a very short reply. 0.97. What is the ratio of the Value added (current US$) in Germany in 2002 to that in 2003?
Your answer should be compact. 0.83. What is the ratio of the Value added (current US$) in Poland in 2002 to that in 2003?
Give a very brief answer. 0.84. What is the ratio of the Value added (current US$) in East Asia (developing only) in 2002 to that in 2004?
Make the answer very short. 0.74. What is the ratio of the Value added (current US$) of Costa Rica in 2002 to that in 2004?
Give a very brief answer. 0.9. What is the ratio of the Value added (current US$) of Germany in 2002 to that in 2004?
Provide a succinct answer. 0.73. What is the ratio of the Value added (current US$) in Poland in 2002 to that in 2004?
Provide a short and direct response. 0.67. What is the ratio of the Value added (current US$) of East Asia (developing only) in 2002 to that in 2005?
Your response must be concise. 0.63. What is the ratio of the Value added (current US$) of Costa Rica in 2002 to that in 2005?
Keep it short and to the point. 0.84. What is the ratio of the Value added (current US$) of Germany in 2002 to that in 2005?
Offer a terse response. 0.71. What is the ratio of the Value added (current US$) of Poland in 2002 to that in 2005?
Offer a terse response. 0.58. What is the ratio of the Value added (current US$) in East Asia (developing only) in 2003 to that in 2004?
Provide a short and direct response. 0.85. What is the ratio of the Value added (current US$) of Costa Rica in 2003 to that in 2004?
Provide a short and direct response. 0.92. What is the ratio of the Value added (current US$) of Germany in 2003 to that in 2004?
Keep it short and to the point. 0.88. What is the ratio of the Value added (current US$) of Poland in 2003 to that in 2004?
Make the answer very short. 0.79. What is the ratio of the Value added (current US$) in East Asia (developing only) in 2003 to that in 2005?
Make the answer very short. 0.73. What is the ratio of the Value added (current US$) of Costa Rica in 2003 to that in 2005?
Your answer should be very brief. 0.86. What is the ratio of the Value added (current US$) of Germany in 2003 to that in 2005?
Your response must be concise. 0.86. What is the ratio of the Value added (current US$) in Poland in 2003 to that in 2005?
Make the answer very short. 0.69. What is the ratio of the Value added (current US$) in East Asia (developing only) in 2004 to that in 2005?
Give a very brief answer. 0.85. What is the ratio of the Value added (current US$) of Costa Rica in 2004 to that in 2005?
Give a very brief answer. 0.94. What is the ratio of the Value added (current US$) in Germany in 2004 to that in 2005?
Ensure brevity in your answer.  0.98. What is the ratio of the Value added (current US$) of Poland in 2004 to that in 2005?
Offer a very short reply. 0.87. What is the difference between the highest and the second highest Value added (current US$) in East Asia (developing only)?
Keep it short and to the point. 1.73e+11. What is the difference between the highest and the second highest Value added (current US$) of Costa Rica?
Provide a short and direct response. 2.38e+08. What is the difference between the highest and the second highest Value added (current US$) in Germany?
Provide a short and direct response. 9.54e+09. What is the difference between the highest and the second highest Value added (current US$) in Poland?
Your answer should be very brief. 6.30e+09. What is the difference between the highest and the lowest Value added (current US$) in East Asia (developing only)?
Your answer should be compact. 5.35e+11. What is the difference between the highest and the lowest Value added (current US$) of Costa Rica?
Provide a succinct answer. 6.72e+08. What is the difference between the highest and the lowest Value added (current US$) of Germany?
Give a very brief answer. 1.81e+11. What is the difference between the highest and the lowest Value added (current US$) of Poland?
Give a very brief answer. 2.16e+1. 